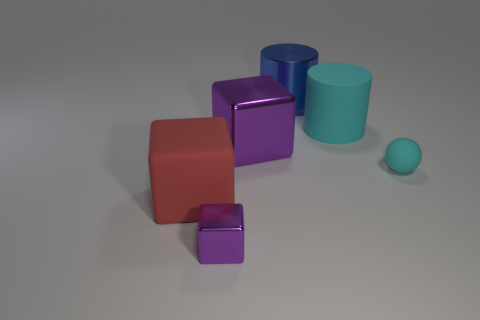Does the tiny metal block have the same color as the large shiny thing in front of the large cyan object?
Offer a terse response. Yes. Is there a red rubber object of the same size as the rubber cylinder?
Your answer should be very brief. Yes. What material is the tiny thing behind the big red thing in front of the large rubber cylinder?
Keep it short and to the point. Rubber. What number of small metallic blocks are the same color as the large metallic cube?
Your answer should be very brief. 1. What is the shape of the tiny purple object that is made of the same material as the large purple cube?
Ensure brevity in your answer.  Cube. There is a purple metal block that is in front of the small rubber ball; how big is it?
Your answer should be very brief. Small. Are there the same number of big red matte things that are on the right side of the tiny cube and large red cubes that are on the right side of the big purple cube?
Ensure brevity in your answer.  Yes. There is a metallic thing on the left side of the purple block right of the purple metallic object that is in front of the matte cube; what is its color?
Your answer should be very brief. Purple. What number of things are both to the right of the matte cube and in front of the large shiny cube?
Provide a short and direct response. 2. Is the color of the tiny thing on the right side of the big purple thing the same as the big rubber object on the right side of the tiny metallic cube?
Make the answer very short. Yes. 